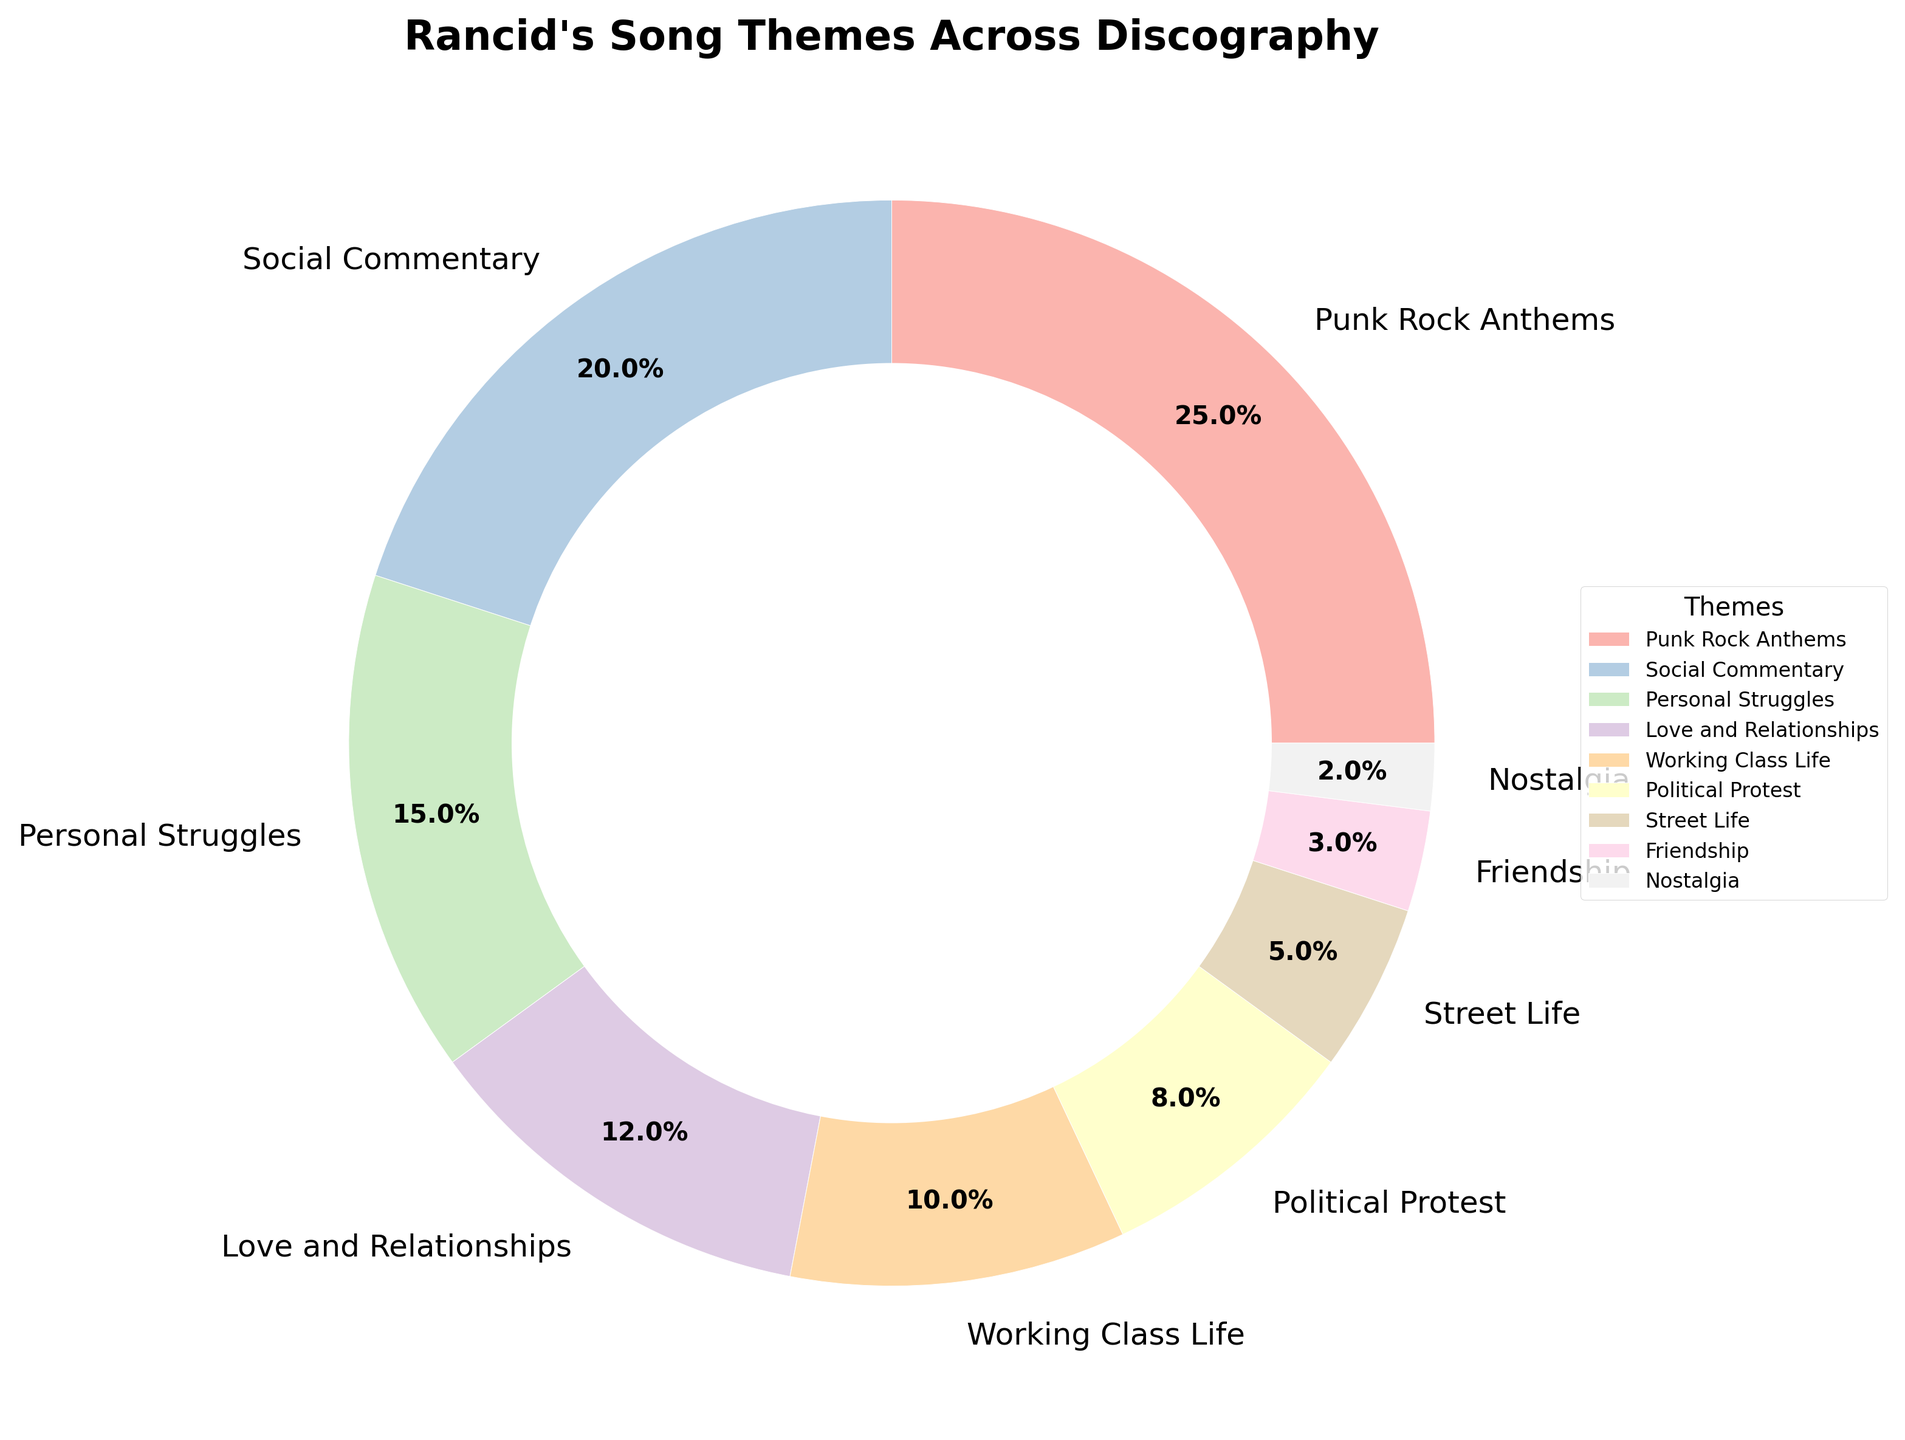What is the most common theme in Rancid's songs? The pie chart shows that 'Punk Rock Anthems' occupies the largest portion of the chart at 25%.
Answer: Punk Rock Anthems Which theme is more prevalent: 'Social Commentary' or 'Personal Struggles'? By comparing the percentages, 'Social Commentary' has 20%, while 'Personal Struggles' has 15%. 20% is greater than 15%.
Answer: Social Commentary What is the percentage range of the themes depicted in the pie chart? The highest percentage is 25% for 'Punk Rock Anthems' and the lowest is 2% for 'Nostalgia'. The range is 25% - 2%.
Answer: 23% How many themes together make up more than 50% of the total? Adding the percentages from highest to lowest: 'Punk Rock Anthems' (25%), 'Social Commentary' (20%), 'Personal Struggles' (15%), and 'Love and Relationships' (12%) sums up to 72%, which is more than 50%.
Answer: 4 Is 'Political Protest' more or less common than 'Working Class Life'? The pie chart shows 'Political Protest' at 8% and 'Working Class Life' at 10%. Since 8% is less than 10%, 'Political Protest' is less common.
Answer: Less common What is the combined percentage of 'Street Life', 'Friendship', and 'Nostalgia' themes? Sum the percentages of 'Street Life' (5%), 'Friendship' (3%), and 'Nostalgia' (2%). 5% + 3% + 2% = 10%.
Answer: 10% Which theme ranks second in prevalence? The second largest portion of the pie chart is occupied by 'Social Commentary' at 20%.
Answer: Social Commentary Are there more themes with above 10% or below 10% representation? Themes above 10% are 'Punk Rock Anthems' (25%), 'Social Commentary' (20%), 'Personal Struggles' (15%), and 'Love and Relationships' (12%), which are 4 themes. Themes below 10% are 'Working Class Life' (10%), 'Political Protest' (8%), 'Street Life' (5%), 'Friendship' (3%), and 'Nostalgia' (2%), which are 5 themes.
Answer: Below 10% Which theme has a lower percentage: 'Love and Relationships' or 'Friendship'? From the chart, 'Love and Relationships' has 12% and 'Friendship' has 3%. 3% is lower than 12%.
Answer: Friendship If the theme 'Working Class Life' increased by 5%, would it surpass 'Personal Struggles' in percentage? If 'Working Class Life' increased by 5%, it would be 10% + 5% = 15%. Since 'Personal Struggles' is also 15%, they would be equal, not surpass.
Answer: No 